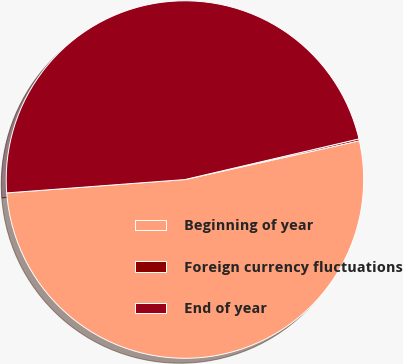<chart> <loc_0><loc_0><loc_500><loc_500><pie_chart><fcel>Beginning of year<fcel>Foreign currency fluctuations<fcel>End of year<nl><fcel>52.29%<fcel>0.17%<fcel>47.54%<nl></chart> 